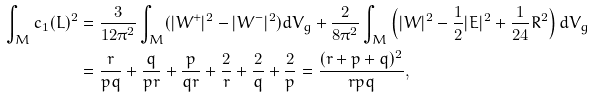<formula> <loc_0><loc_0><loc_500><loc_500>\int _ { M } c _ { 1 } ( L ) ^ { 2 } & = \frac { 3 } { 1 2 \pi ^ { 2 } } \int _ { M } ( | W ^ { + } | ^ { 2 } - | W ^ { - } | ^ { 2 } ) d V _ { g } + \frac { 2 } { 8 \pi ^ { 2 } } \int _ { M } \left ( | W | ^ { 2 } - \frac { 1 } { 2 } | E | ^ { 2 } + \frac { 1 } { 2 4 } R ^ { 2 } \right ) d V _ { g } \\ & = \frac { r } { p q } + \frac { q } { p r } + \frac { p } { q r } + \frac { 2 } { r } + \frac { 2 } { q } + \frac { 2 } { p } = \frac { ( r + p + q ) ^ { 2 } } { r p q } ,</formula> 